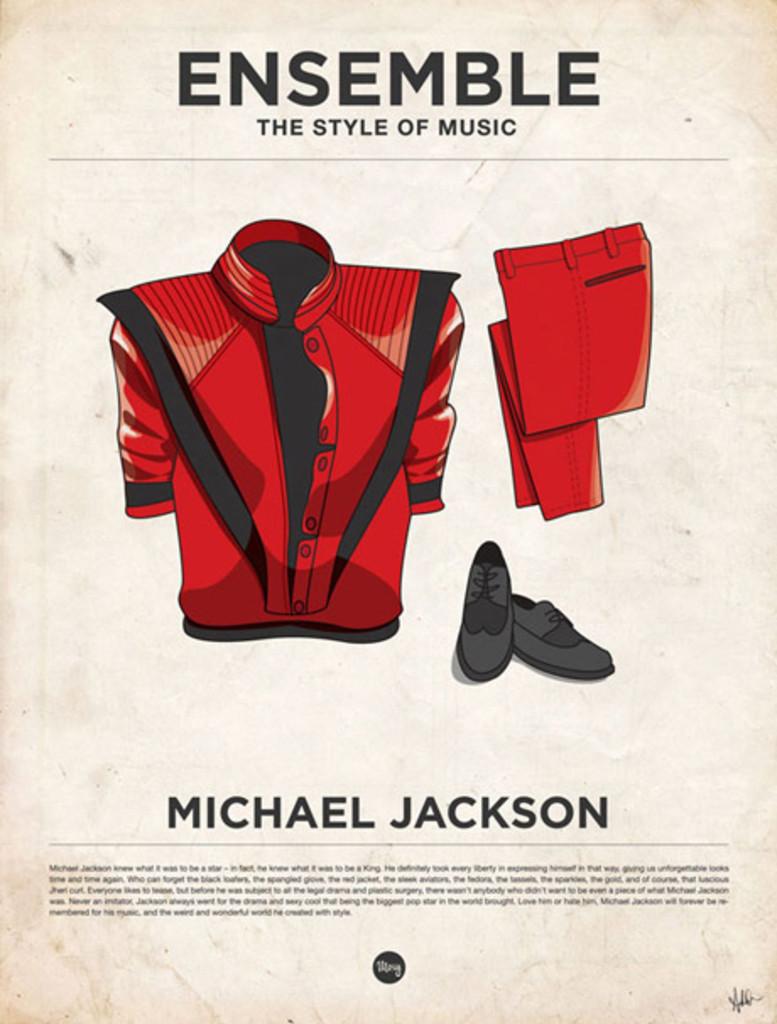What is this michael jackson ad saying?
Offer a very short reply. Ensemble. What is the ad about?
Offer a terse response. Michael jackson. 